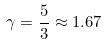Convert formula to latex. <formula><loc_0><loc_0><loc_500><loc_500>\gamma = \frac { 5 } { 3 } \approx 1 . 6 7</formula> 